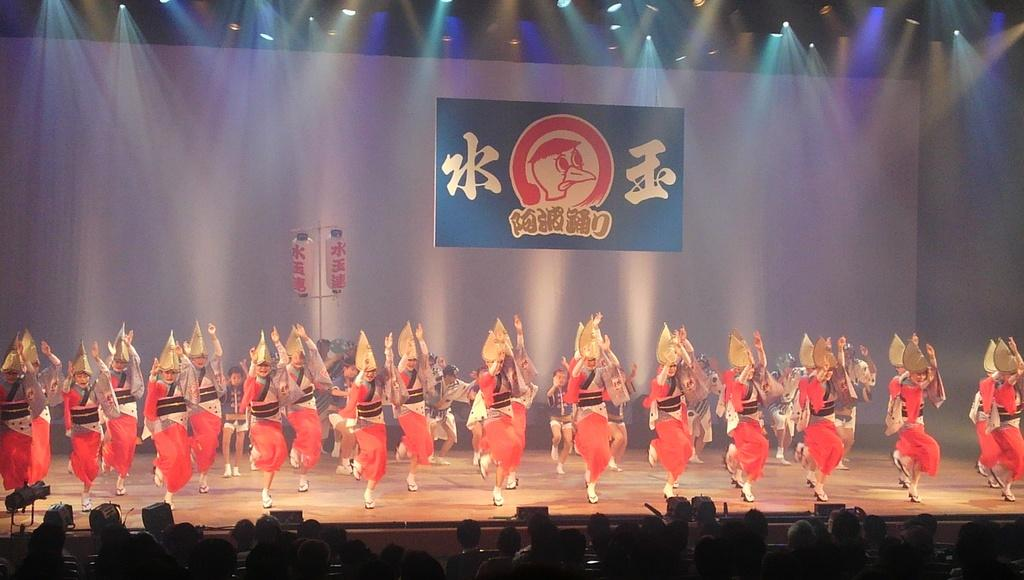What are the people in the image wearing? The people in the image are wearing different color costumes. Where are the people in the image located? The people are on a stage. What can be seen in the background behind the stage? There is a blue board and lights visible in the background. What is happening in front of the stage? There are people in front of the stage. What type of theory is being discussed by the people in the image? There is no indication in the image that the people are discussing any theory. 